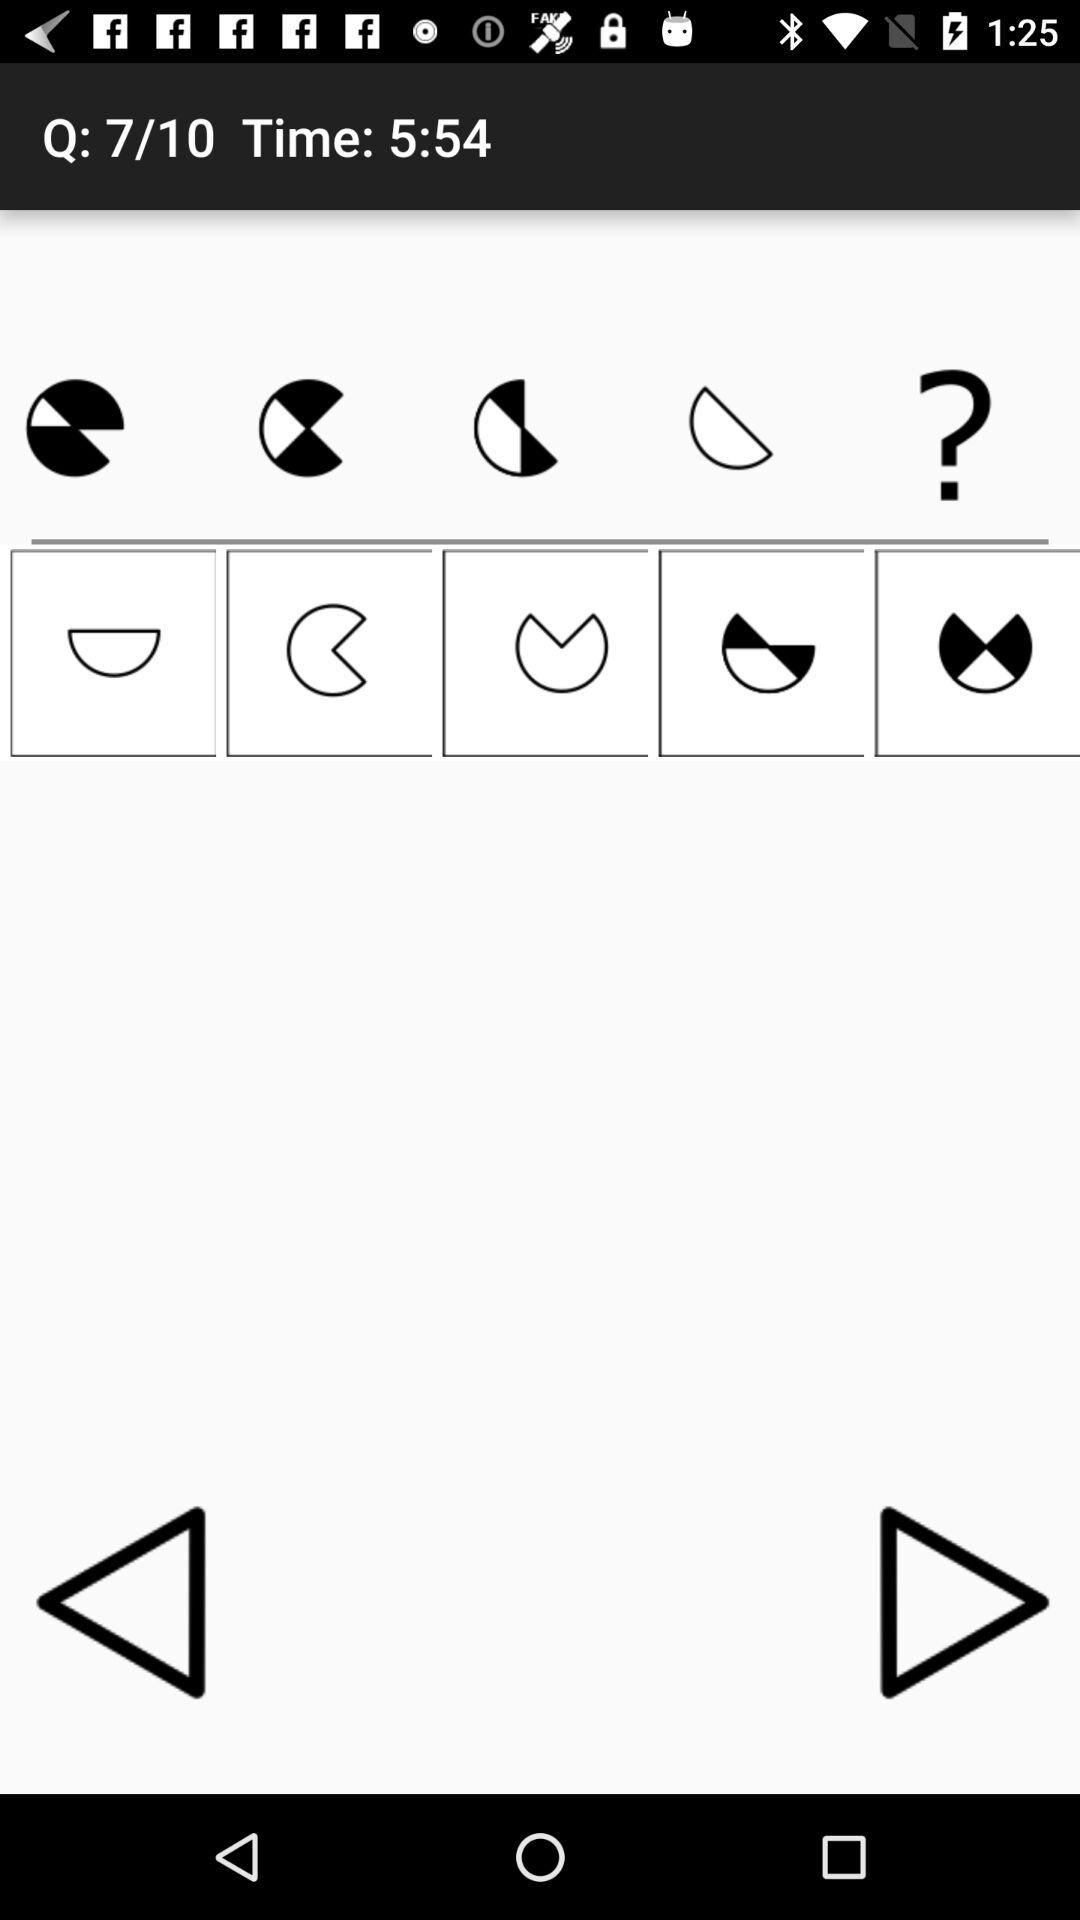What is the total number of questions? The total number of questions is 10. 